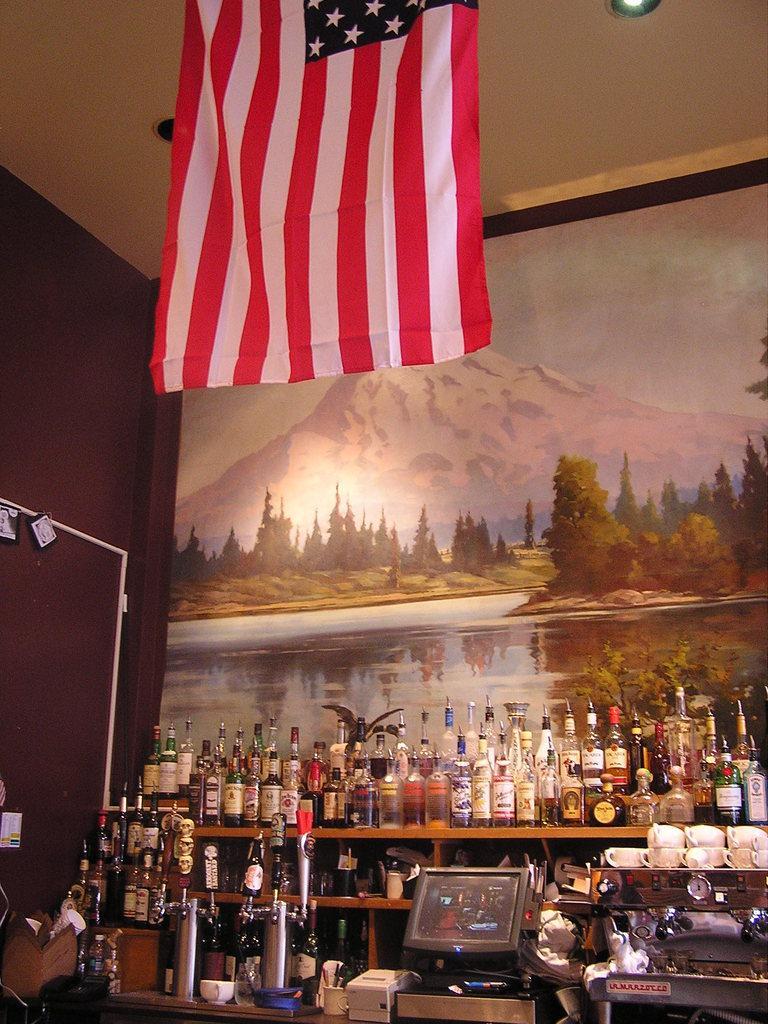Could you give a brief overview of what you see in this image? There are some bottle kept in a shelf at the bottom of this image, and there is a painting wall in the background. There is a flag at the top of this image. 